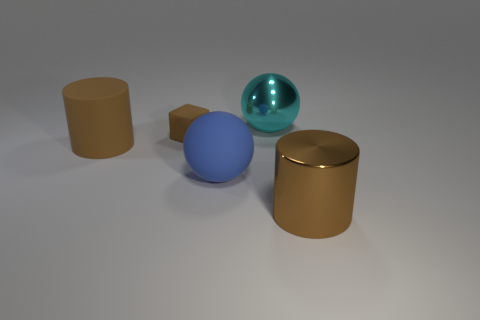Add 4 big brown matte things. How many objects exist? 9 Subtract all balls. How many objects are left? 3 Add 2 large metal spheres. How many large metal spheres are left? 3 Add 1 small brown matte objects. How many small brown matte objects exist? 2 Subtract 0 purple cylinders. How many objects are left? 5 Subtract all large green rubber spheres. Subtract all big blue rubber spheres. How many objects are left? 4 